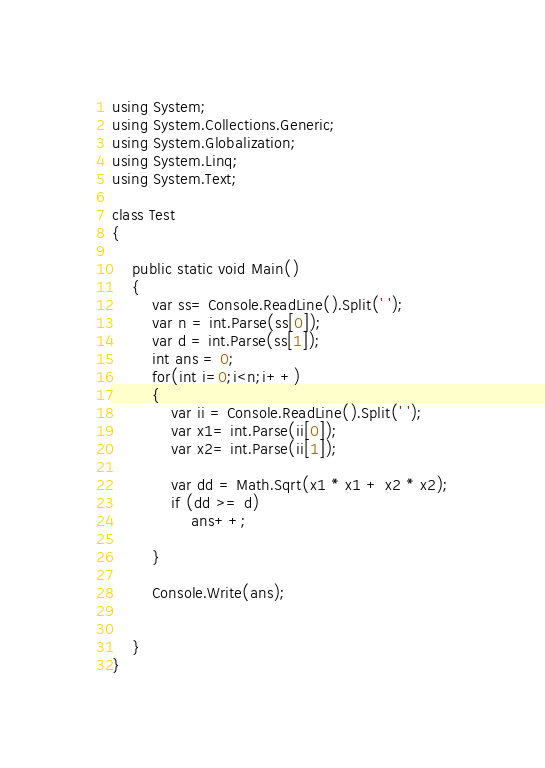<code> <loc_0><loc_0><loc_500><loc_500><_C#_>using System;
using System.Collections.Generic;
using System.Globalization;
using System.Linq;
using System.Text;

class Test
{

    public static void Main()
    {
        var ss= Console.ReadLine().Split(' ');
        var n = int.Parse(ss[0]);
        var d = int.Parse(ss[1]);
        int ans = 0;
        for(int i=0;i<n;i++)
        {
            var ii = Console.ReadLine().Split(' ');
            var x1= int.Parse(ii[0]);
            var x2= int.Parse(ii[1]);

            var dd = Math.Sqrt(x1 * x1 + x2 * x2);
            if (dd >= d)
                ans++;

        }

        Console.Write(ans);


    }
}



</code> 